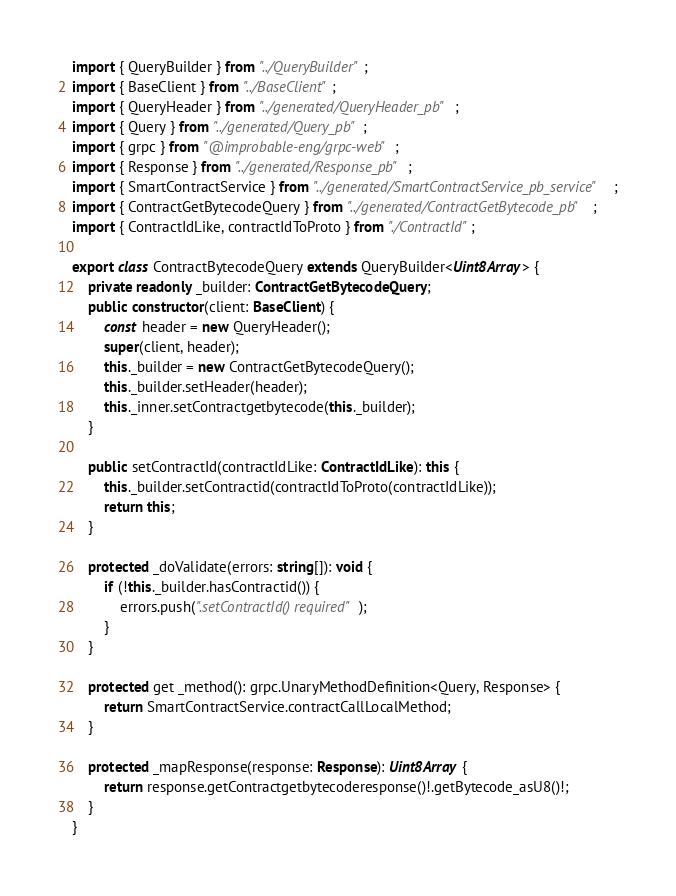<code> <loc_0><loc_0><loc_500><loc_500><_TypeScript_>import { QueryBuilder } from "../QueryBuilder";
import { BaseClient } from "../BaseClient";
import { QueryHeader } from "../generated/QueryHeader_pb";
import { Query } from "../generated/Query_pb";
import { grpc } from "@improbable-eng/grpc-web";
import { Response } from "../generated/Response_pb";
import { SmartContractService } from "../generated/SmartContractService_pb_service";
import { ContractGetBytecodeQuery } from "../generated/ContractGetBytecode_pb";
import { ContractIdLike, contractIdToProto } from "./ContractId";

export class ContractBytecodeQuery extends QueryBuilder<Uint8Array> {
    private readonly _builder: ContractGetBytecodeQuery;
    public constructor(client: BaseClient) {
        const header = new QueryHeader();
        super(client, header);
        this._builder = new ContractGetBytecodeQuery();
        this._builder.setHeader(header);
        this._inner.setContractgetbytecode(this._builder);
    }

    public setContractId(contractIdLike: ContractIdLike): this {
        this._builder.setContractid(contractIdToProto(contractIdLike));
        return this;
    }

    protected _doValidate(errors: string[]): void {
        if (!this._builder.hasContractid()) {
            errors.push(".setContractId() required");
        }
    }

    protected get _method(): grpc.UnaryMethodDefinition<Query, Response> {
        return SmartContractService.contractCallLocalMethod;
    }

    protected _mapResponse(response: Response): Uint8Array {
        return response.getContractgetbytecoderesponse()!.getBytecode_asU8()!;
    }
}
</code> 